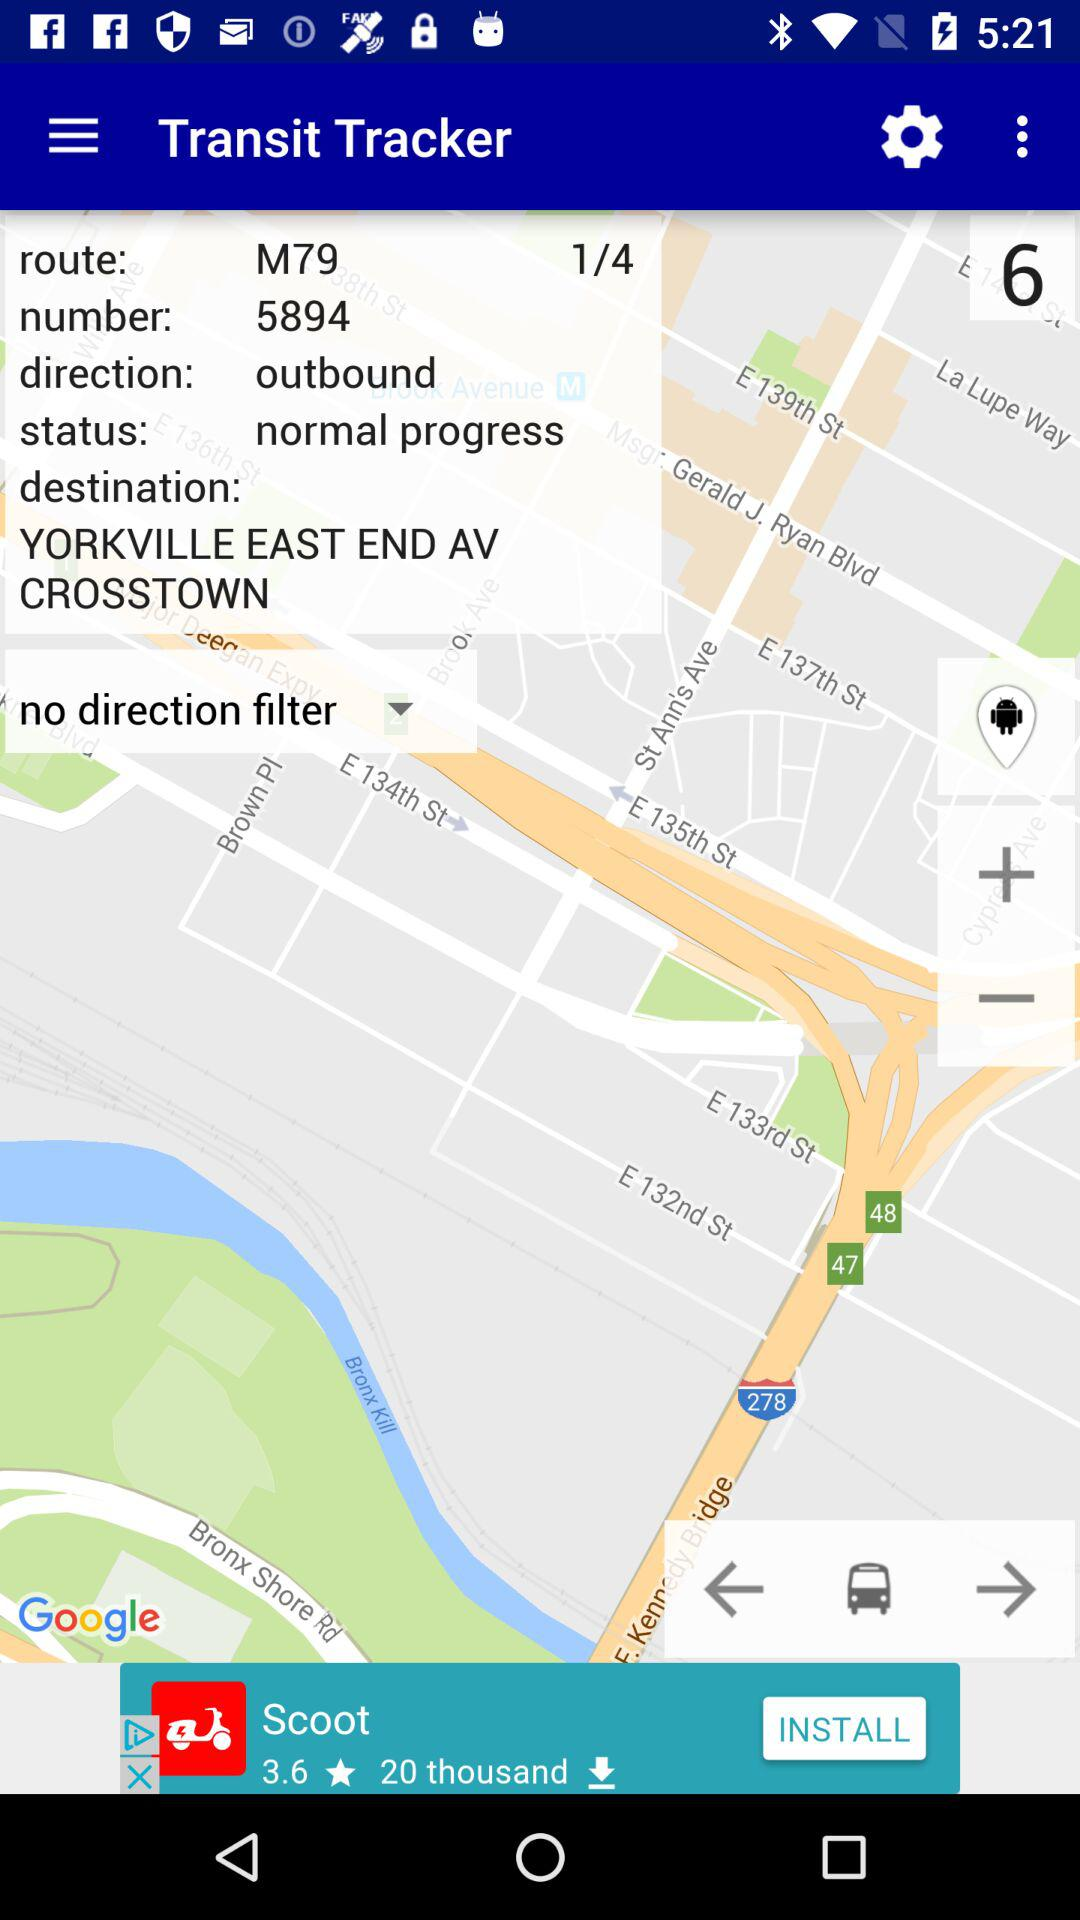What is the number? The number is 5894. 